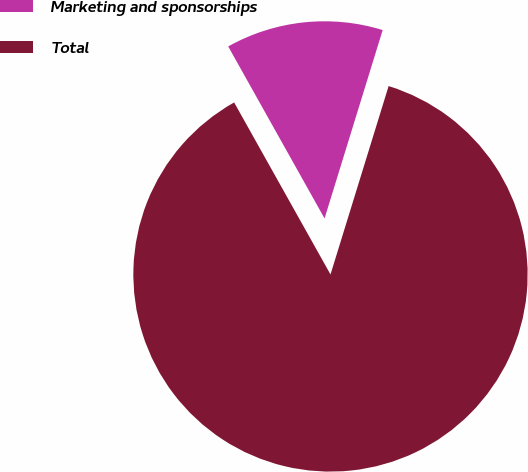Convert chart. <chart><loc_0><loc_0><loc_500><loc_500><pie_chart><fcel>Marketing and sponsorships<fcel>Total<nl><fcel>12.89%<fcel>87.11%<nl></chart> 